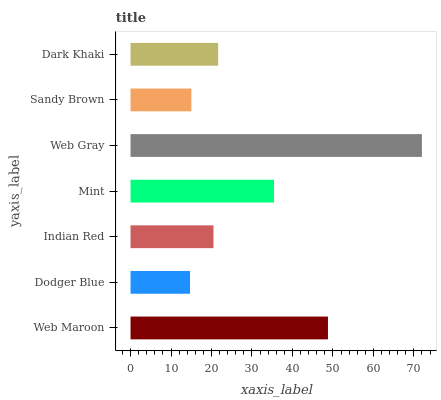Is Dodger Blue the minimum?
Answer yes or no. Yes. Is Web Gray the maximum?
Answer yes or no. Yes. Is Indian Red the minimum?
Answer yes or no. No. Is Indian Red the maximum?
Answer yes or no. No. Is Indian Red greater than Dodger Blue?
Answer yes or no. Yes. Is Dodger Blue less than Indian Red?
Answer yes or no. Yes. Is Dodger Blue greater than Indian Red?
Answer yes or no. No. Is Indian Red less than Dodger Blue?
Answer yes or no. No. Is Dark Khaki the high median?
Answer yes or no. Yes. Is Dark Khaki the low median?
Answer yes or no. Yes. Is Mint the high median?
Answer yes or no. No. Is Web Gray the low median?
Answer yes or no. No. 